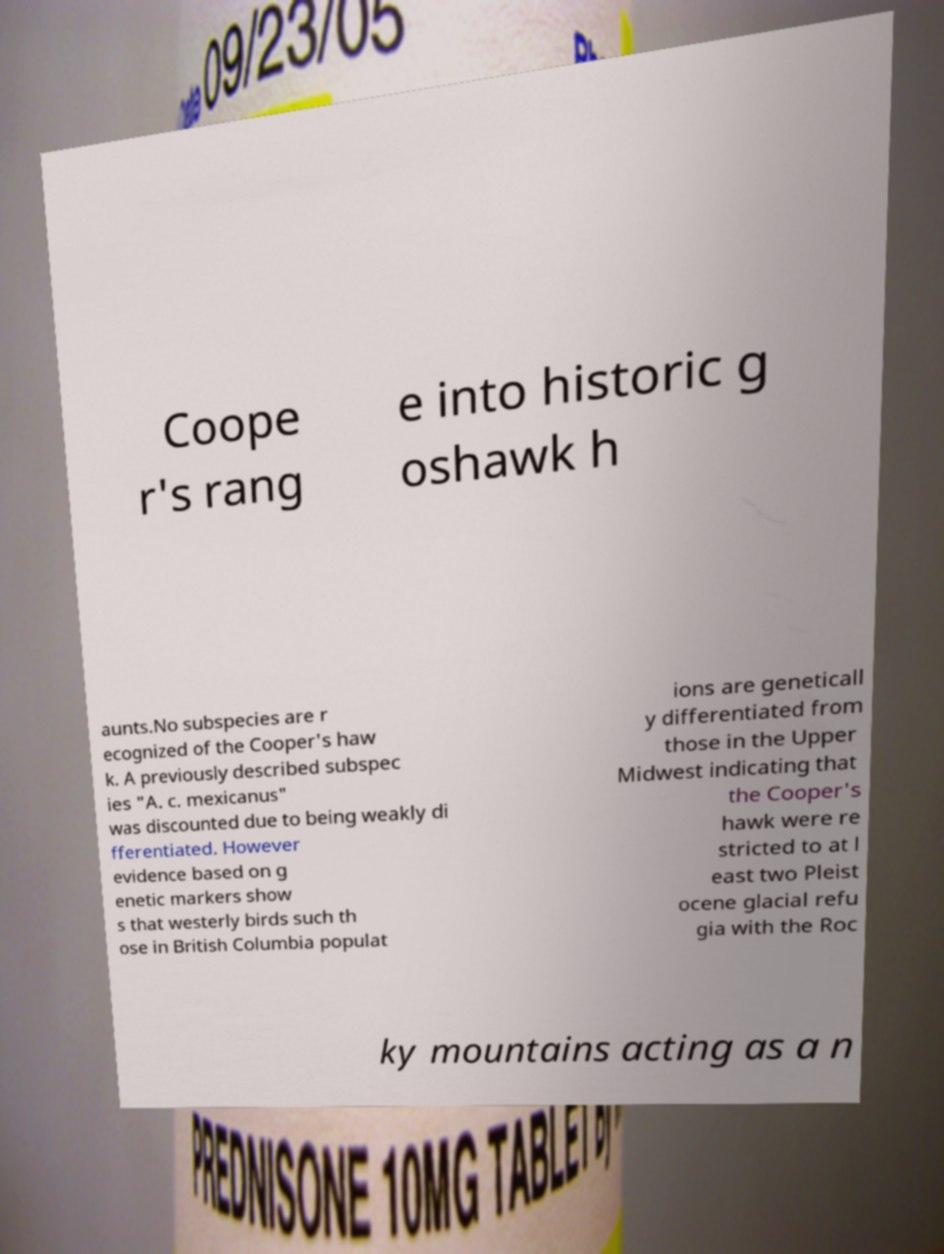Please identify and transcribe the text found in this image. Coope r's rang e into historic g oshawk h aunts.No subspecies are r ecognized of the Cooper's haw k. A previously described subspec ies "A. c. mexicanus" was discounted due to being weakly di fferentiated. However evidence based on g enetic markers show s that westerly birds such th ose in British Columbia populat ions are geneticall y differentiated from those in the Upper Midwest indicating that the Cooper's hawk were re stricted to at l east two Pleist ocene glacial refu gia with the Roc ky mountains acting as a n 